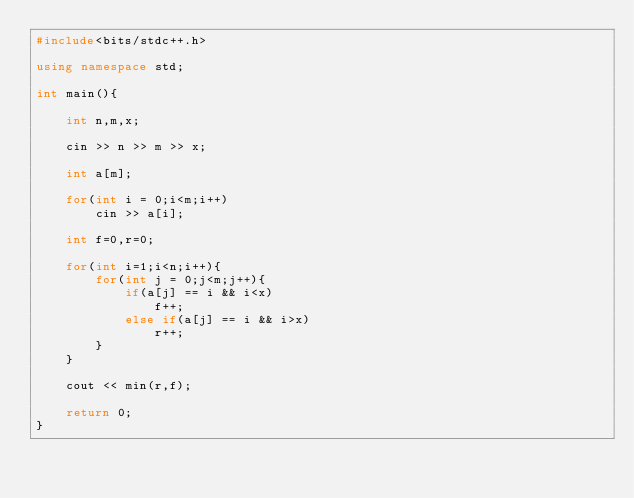Convert code to text. <code><loc_0><loc_0><loc_500><loc_500><_C++_>#include<bits/stdc++.h>

using namespace std;

int main(){
	
	int n,m,x;
	
	cin >> n >> m >> x;
	
	int a[m];
	
	for(int i = 0;i<m;i++)
		cin >> a[i];
	
	int f=0,r=0;
	
	for(int i=1;i<n;i++){
		for(int j = 0;j<m;j++){
			if(a[j] == i && i<x)
				f++;
			else if(a[j] == i && i>x)
				r++;
		}
	}
	
	cout << min(r,f);
	
	return 0;
}</code> 